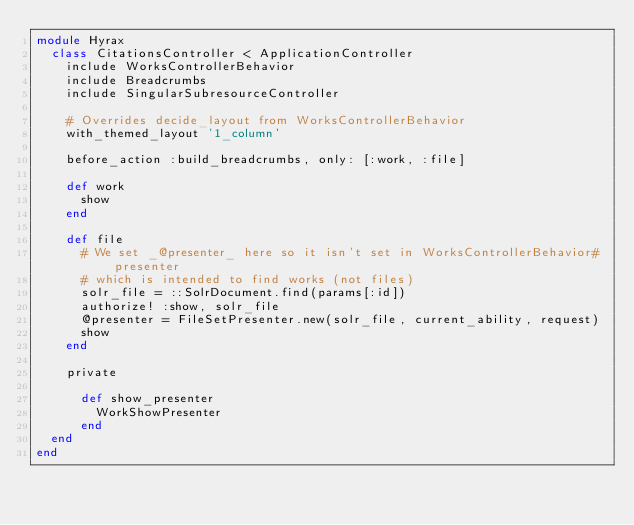Convert code to text. <code><loc_0><loc_0><loc_500><loc_500><_Ruby_>module Hyrax
  class CitationsController < ApplicationController
    include WorksControllerBehavior
    include Breadcrumbs
    include SingularSubresourceController

    # Overrides decide_layout from WorksControllerBehavior
    with_themed_layout '1_column'

    before_action :build_breadcrumbs, only: [:work, :file]

    def work
      show
    end

    def file
      # We set _@presenter_ here so it isn't set in WorksControllerBehavior#presenter
      # which is intended to find works (not files)
      solr_file = ::SolrDocument.find(params[:id])
      authorize! :show, solr_file
      @presenter = FileSetPresenter.new(solr_file, current_ability, request)
      show
    end

    private

      def show_presenter
        WorkShowPresenter
      end
  end
end
</code> 